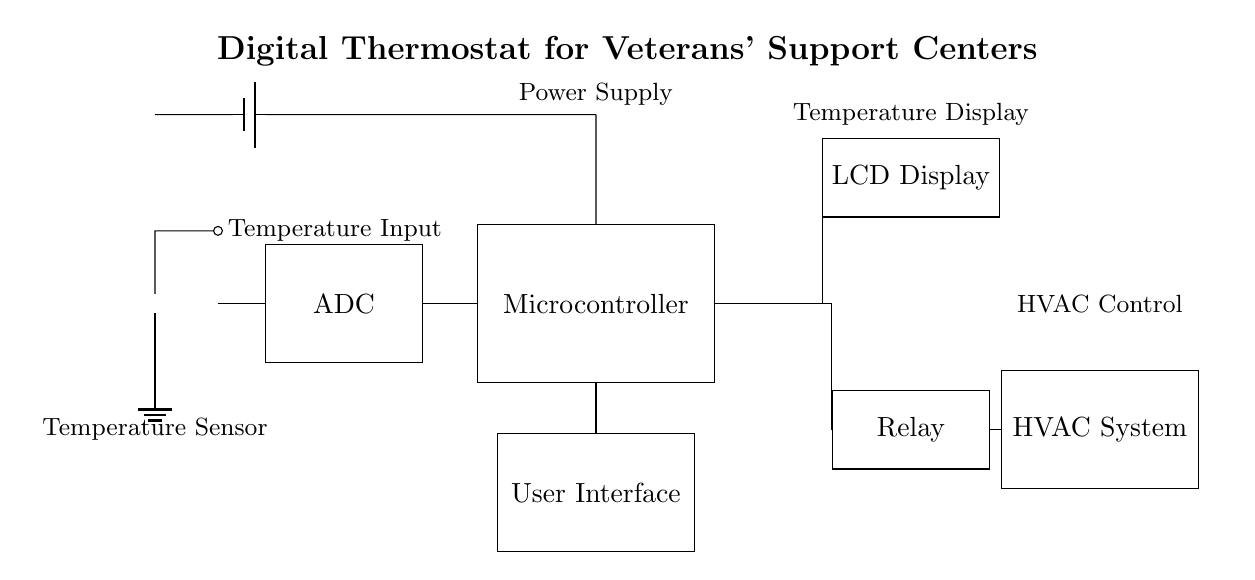What component is responsible for sensing temperature? The component responsible for sensing temperature is the thermistor, which detects changes in temperature and produces an appropriate resistance change that correlates with temperature variations.
Answer: thermistor What connects the temperature sensor to the ADC? The temperature sensor connects to the ADC through a wire (short connection) that transmits the sensor's resistance value for conversion to a digital signal.
Answer: wire Which element displays the current temperature? The LCD Display shows the current temperature by interfacing with the microcontroller, which processes the readings received from the ADC.
Answer: LCD Display What is the role of the microcontroller in this circuit? The microcontroller processes the digital signal from the ADC, makes decisions based on the input, and controls the relay to adjust the HVAC system accordingly.
Answer: process and control How does the relay impact the HVAC system? The relay acts as a switch that controls the HVAC system based on the commands received from the microcontroller, turning the system on or off as needed to maintain the desired temperature.
Answer: on/off control What is the power source for the entire circuit? The circuit is powered by a battery, which supplies voltage to all components, ensuring they operate correctly for efficient temperature control.
Answer: battery What type of control system does this circuit implement? This circuit implements a digital control system that combines analog temperature sensing with digital processing and control to efficiently manage HVAC operation.
Answer: digital control system 